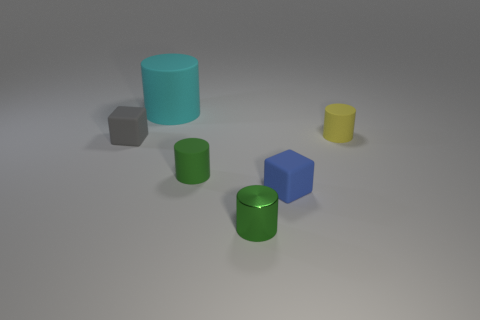What is the color of the other rubber cylinder that is the same size as the yellow rubber cylinder?
Give a very brief answer. Green. How many rubber objects are either yellow cylinders or small blue objects?
Keep it short and to the point. 2. There is a small block right of the large object; what number of small green shiny cylinders are in front of it?
Keep it short and to the point. 1. There is another cylinder that is the same color as the small shiny cylinder; what is its size?
Keep it short and to the point. Small. What number of objects are either green metal cylinders or small rubber cubes that are right of the metal object?
Keep it short and to the point. 2. Is there a big cyan thing made of the same material as the small gray block?
Offer a very short reply. Yes. What number of matte cubes are left of the small metallic object and to the right of the metallic object?
Your answer should be compact. 0. What is the material of the small green cylinder that is to the right of the tiny green matte object?
Provide a short and direct response. Metal. There is another yellow cylinder that is the same material as the large cylinder; what size is it?
Make the answer very short. Small. There is a big cylinder; are there any small blue cubes in front of it?
Offer a very short reply. Yes. 